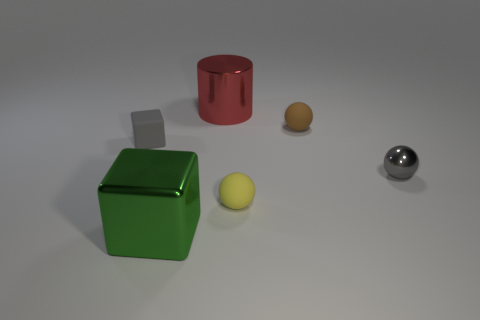What number of other objects are there of the same color as the cylinder?
Make the answer very short. 0. There is a thing that is right of the cylinder and behind the rubber block; what is its color?
Offer a very short reply. Brown. What size is the rubber object to the right of the small yellow ball that is to the right of the small object that is on the left side of the big red thing?
Offer a very short reply. Small. What number of things are objects that are on the right side of the big green metallic object or big shiny objects that are in front of the large red metal cylinder?
Offer a terse response. 5. What is the shape of the green thing?
Your answer should be very brief. Cube. How many other objects are the same material as the tiny yellow ball?
Ensure brevity in your answer.  2. There is a brown matte thing that is the same shape as the small shiny object; what size is it?
Make the answer very short. Small. What is the thing behind the ball behind the tiny object to the left of the big red shiny cylinder made of?
Your answer should be very brief. Metal. Are there any brown balls?
Ensure brevity in your answer.  Yes. Does the small metallic object have the same color as the matte thing on the left side of the metallic cylinder?
Provide a short and direct response. Yes. 